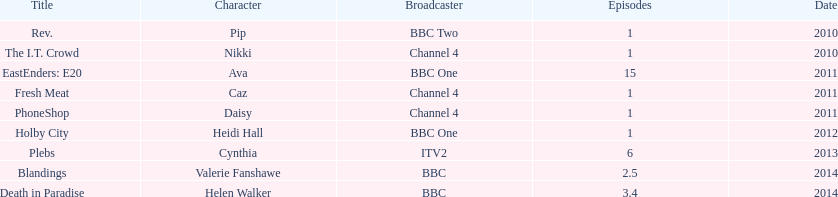What is the total number of shows sophie colguhoun appeared in? 9. 